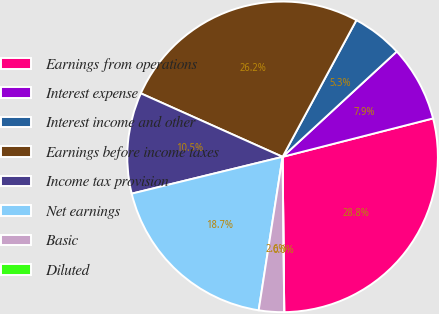Convert chart. <chart><loc_0><loc_0><loc_500><loc_500><pie_chart><fcel>Earnings from operations<fcel>Interest expense<fcel>Interest income and other<fcel>Earnings before income taxes<fcel>Income tax provision<fcel>Net earnings<fcel>Basic<fcel>Diluted<nl><fcel>28.81%<fcel>7.88%<fcel>5.26%<fcel>26.18%<fcel>10.51%<fcel>18.73%<fcel>2.63%<fcel>0.0%<nl></chart> 